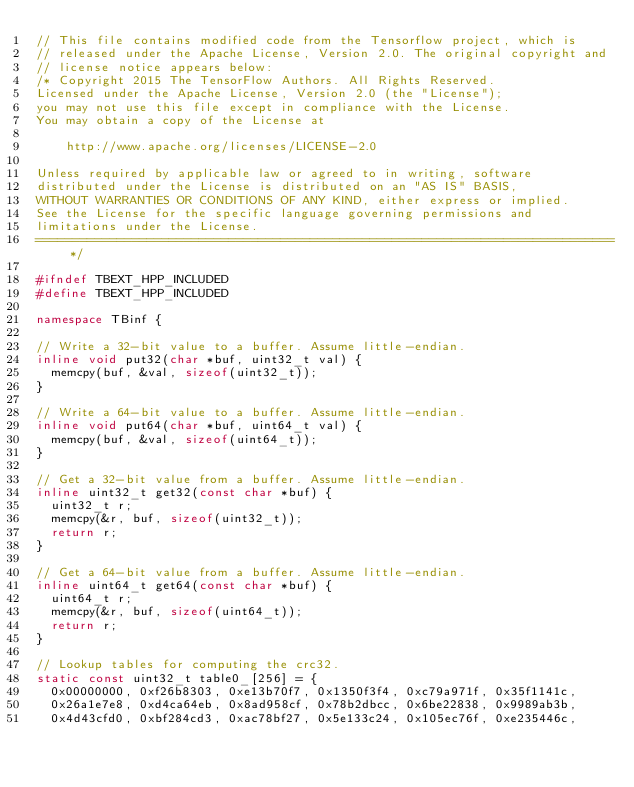<code> <loc_0><loc_0><loc_500><loc_500><_C++_>// This file contains modified code from the Tensorflow project, which is
// released under the Apache License, Version 2.0. The original copyright and
// license notice appears below:
/* Copyright 2015 The TensorFlow Authors. All Rights Reserved.
Licensed under the Apache License, Version 2.0 (the "License");
you may not use this file except in compliance with the License.
You may obtain a copy of the License at

    http://www.apache.org/licenses/LICENSE-2.0

Unless required by applicable law or agreed to in writing, software
distributed under the License is distributed on an "AS IS" BASIS,
WITHOUT WARRANTIES OR CONDITIONS OF ANY KIND, either express or implied.
See the License for the specific language governing permissions and
limitations under the License.
==============================================================================*/

#ifndef TBEXT_HPP_INCLUDED
#define TBEXT_HPP_INCLUDED

namespace TBinf {

// Write a 32-bit value to a buffer. Assume little-endian.
inline void put32(char *buf, uint32_t val) {
  memcpy(buf, &val, sizeof(uint32_t));
}

// Write a 64-bit value to a buffer. Assume little-endian.
inline void put64(char *buf, uint64_t val) {
  memcpy(buf, &val, sizeof(uint64_t));
}

// Get a 32-bit value from a buffer. Assume little-endian.
inline uint32_t get32(const char *buf) {
  uint32_t r;
  memcpy(&r, buf, sizeof(uint32_t));
  return r;
}

// Get a 64-bit value from a buffer. Assume little-endian.
inline uint64_t get64(const char *buf) {
  uint64_t r;
  memcpy(&r, buf, sizeof(uint64_t));
  return r;
}

// Lookup tables for computing the crc32.
static const uint32_t table0_[256] = {
  0x00000000, 0xf26b8303, 0xe13b70f7, 0x1350f3f4, 0xc79a971f, 0x35f1141c,
  0x26a1e7e8, 0xd4ca64eb, 0x8ad958cf, 0x78b2dbcc, 0x6be22838, 0x9989ab3b,
  0x4d43cfd0, 0xbf284cd3, 0xac78bf27, 0x5e133c24, 0x105ec76f, 0xe235446c,</code> 